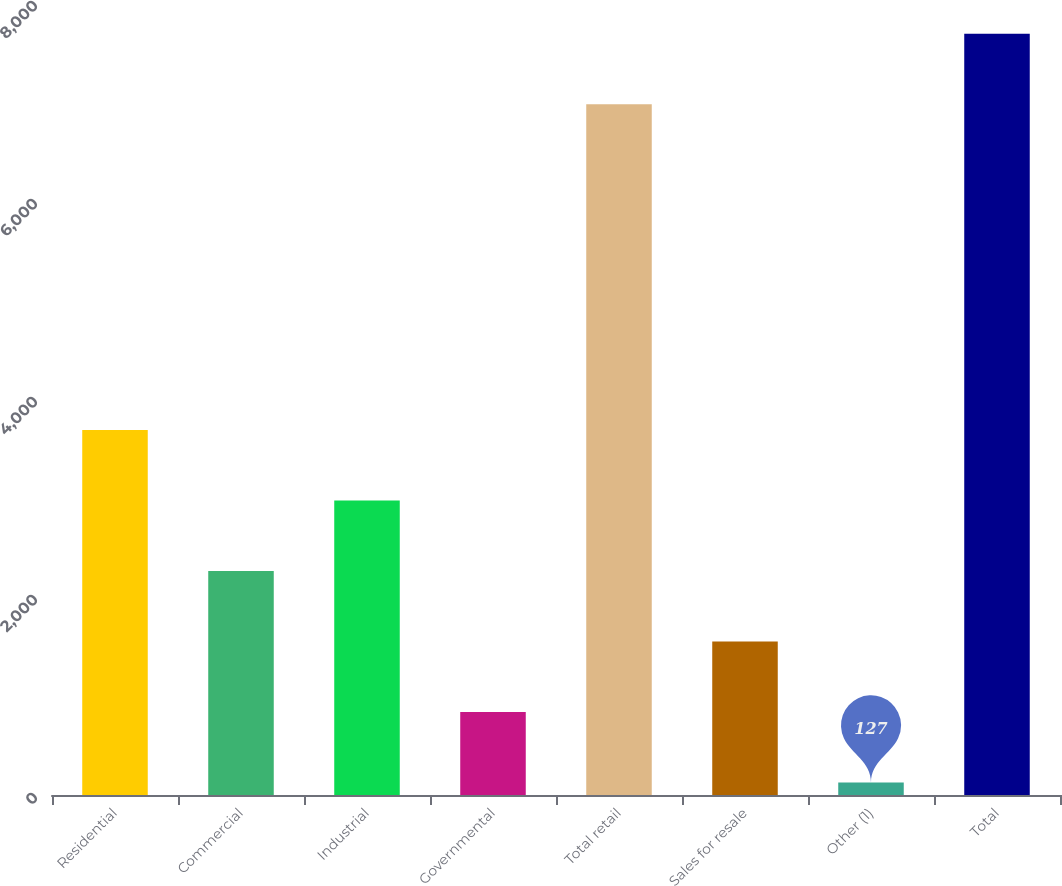<chart> <loc_0><loc_0><loc_500><loc_500><bar_chart><fcel>Residential<fcel>Commercial<fcel>Industrial<fcel>Governmental<fcel>Total retail<fcel>Sales for resale<fcel>Other (1)<fcel>Total<nl><fcel>3686<fcel>2262.4<fcel>2974.2<fcel>838.8<fcel>6977<fcel>1550.6<fcel>127<fcel>7688.8<nl></chart> 